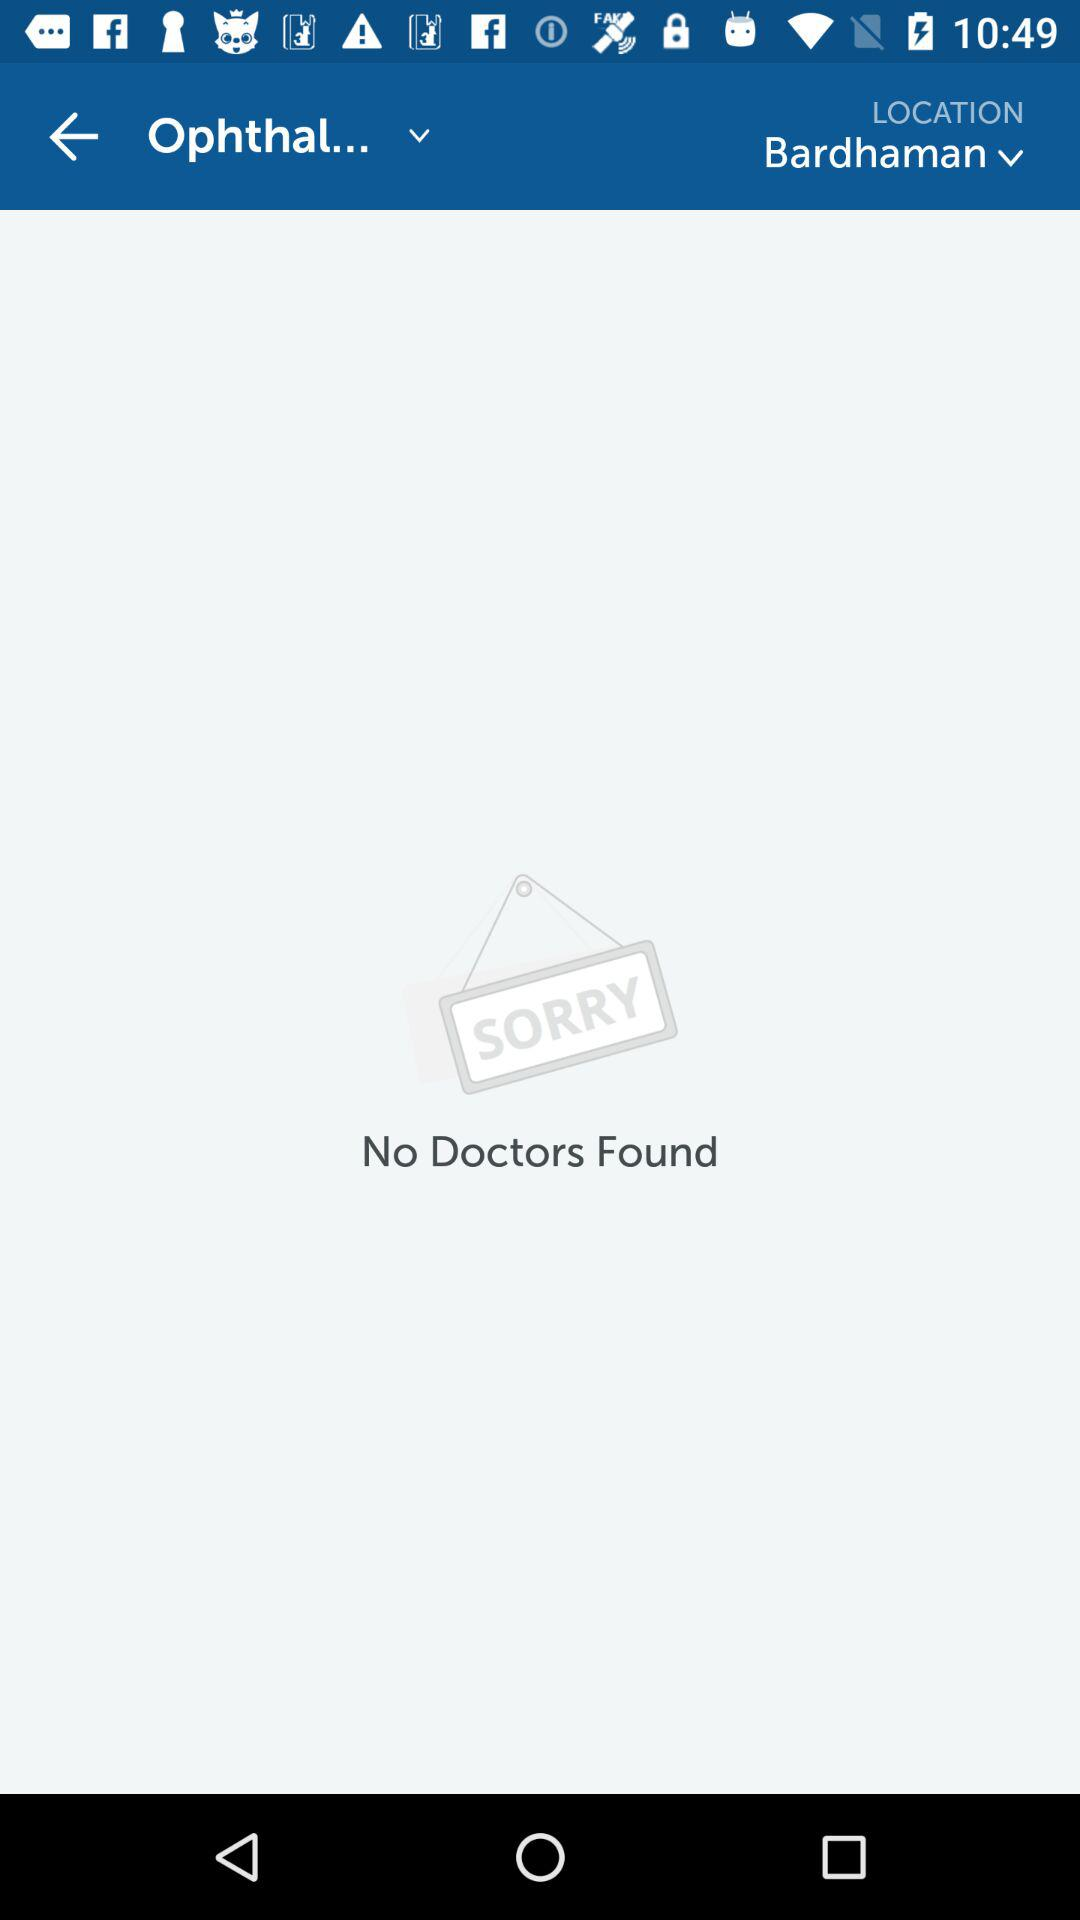Is there any doctor? No, there is no doctor found. 